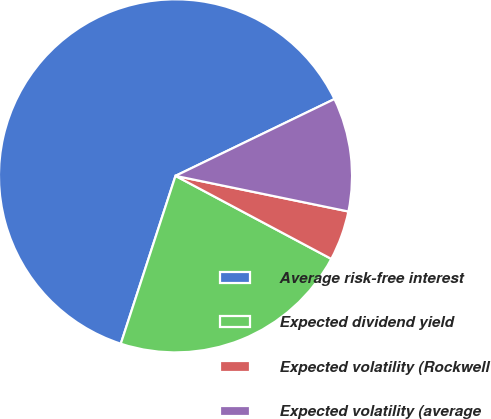Convert chart to OTSL. <chart><loc_0><loc_0><loc_500><loc_500><pie_chart><fcel>Average risk-free interest<fcel>Expected dividend yield<fcel>Expected volatility (Rockwell<fcel>Expected volatility (average<nl><fcel>62.82%<fcel>22.22%<fcel>4.56%<fcel>10.4%<nl></chart> 